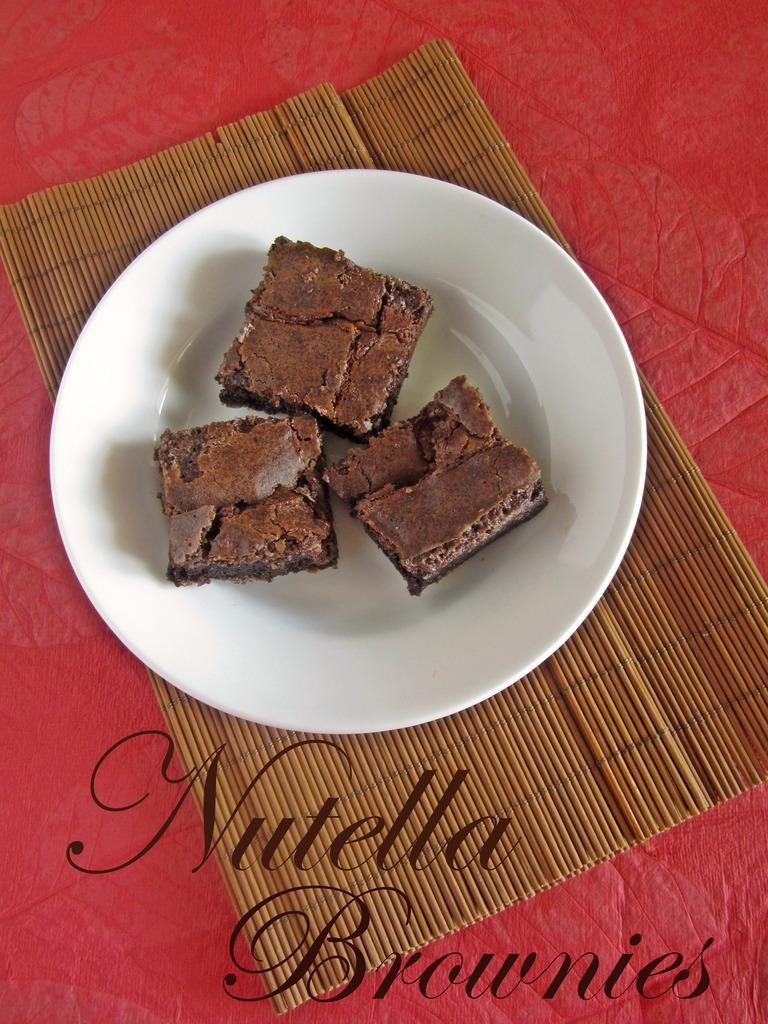Could you give a brief overview of what you see in this image? In this picture, we see a white plate containing three cake pieces is placed on the wooden mat. In the background, it is red in color. At the bottom, we see some text written. 